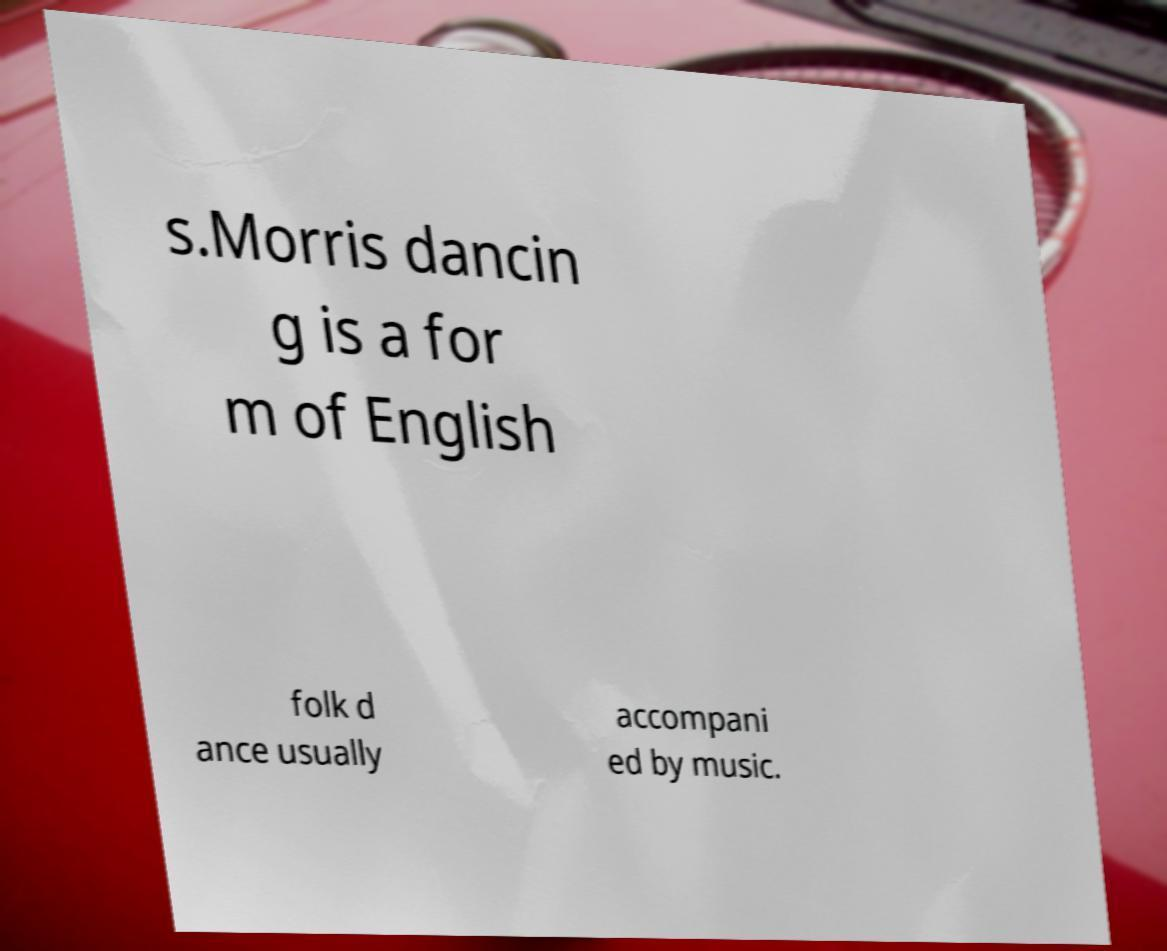Could you extract and type out the text from this image? s.Morris dancin g is a for m of English folk d ance usually accompani ed by music. 